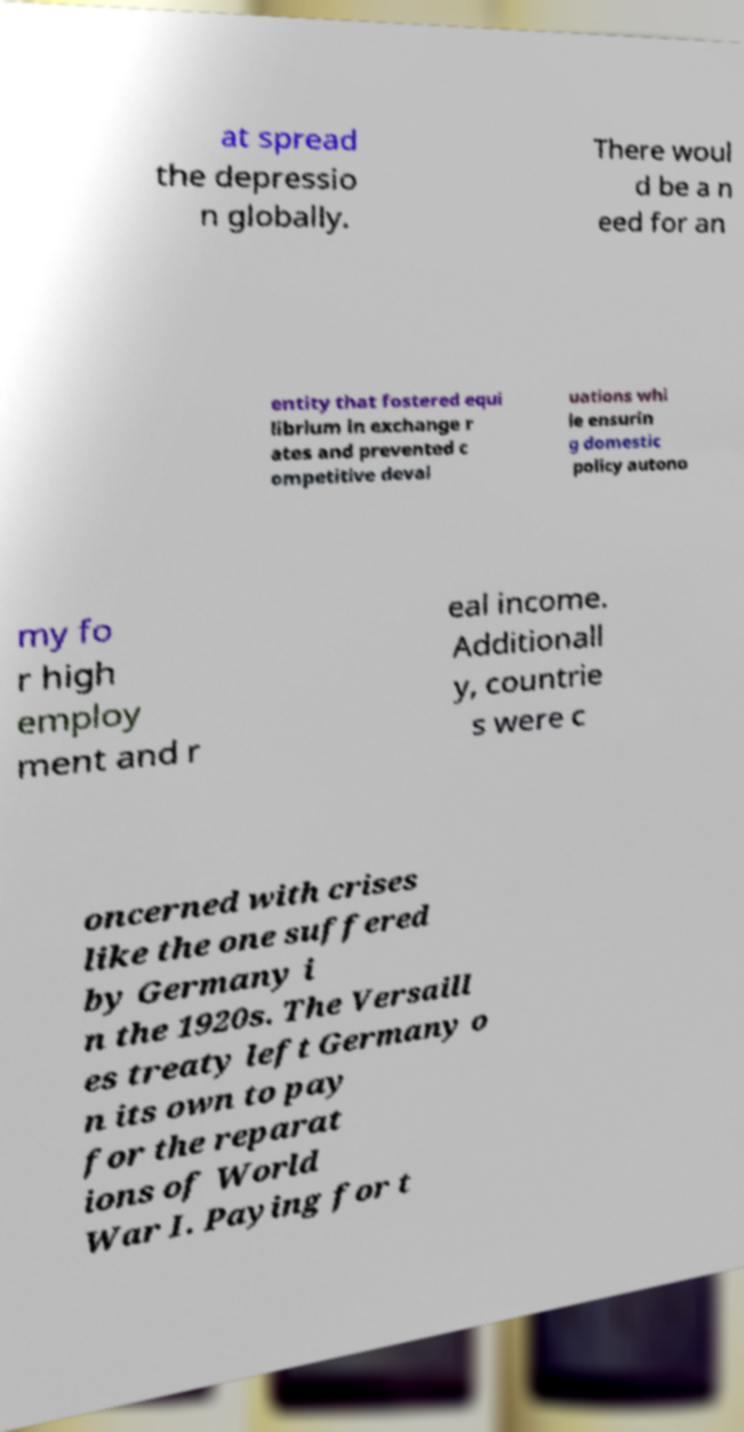There's text embedded in this image that I need extracted. Can you transcribe it verbatim? at spread the depressio n globally. There woul d be a n eed for an entity that fostered equi librium in exchange r ates and prevented c ompetitive deval uations whi le ensurin g domestic policy autono my fo r high employ ment and r eal income. Additionall y, countrie s were c oncerned with crises like the one suffered by Germany i n the 1920s. The Versaill es treaty left Germany o n its own to pay for the reparat ions of World War I. Paying for t 